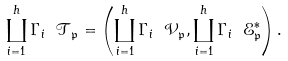Convert formula to latex. <formula><loc_0><loc_0><loc_500><loc_500>\coprod _ { i = 1 } ^ { h } \Gamma _ { i } \ \mathcal { T } _ { \mathfrak { p } } = \left ( \coprod _ { i = 1 } ^ { h } \Gamma _ { i } \ \mathcal { V } _ { \mathfrak { p } } , \coprod _ { i = 1 } ^ { h } \Gamma _ { i } \ \mathcal { E } _ { \mathfrak { p } } ^ { * } \right ) .</formula> 